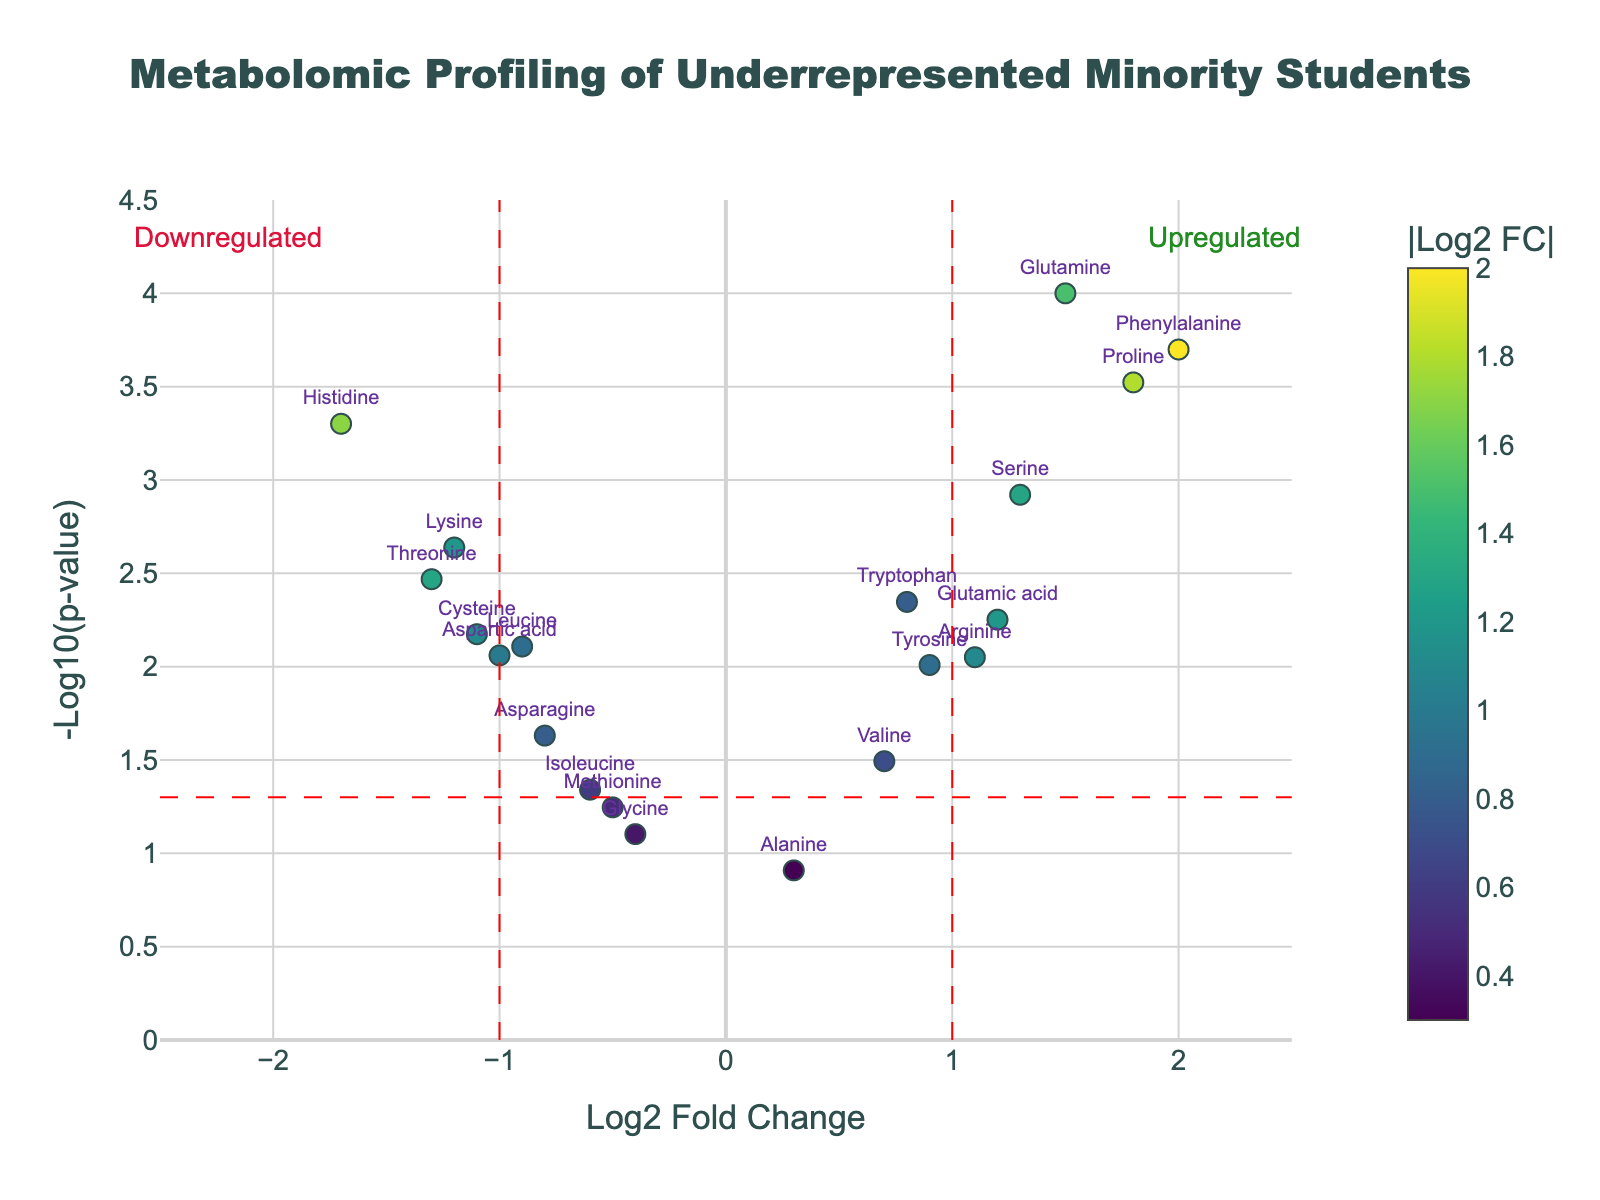How many metabolites have a statistically significant p-value? Statistically significant p-values are typically below 0.05. By examining the y-axis and locating the points above the red-dashed horizontal line (representing the p-value threshold), we can count 15 metabolites as significant.
Answer: 15 Which metabolite has the highest log2 fold change and what is its p-value? To find the metabolite with the highest log2 fold change, look at the x-axis for the data point farthest to the right. The highest log2 fold change (2.0) belongs to Phenylalanine. Its hover text or label provides the p-value, which is 0.0002.
Answer: Phenylalanine, 0.0002 Which metabolite shows the most significant downregulation? The most downregulated metabolite is the one with the lowest log2 fold change on the x-axis. Histidine, with a log2 fold change of -1.7, is the most downregulated, and its p-value is 0.0005.
Answer: Histidine, 0.0005 How many metabolites have a log2 fold change between 1 and -1? Count the number of data points visible between the vertical dashed lines at x = -1 and x = 1 on the x-axis. There are 9 metabolites within this range.
Answer: 9 Which metabolite displayed a significant change but has the least change in log2 fold? The least change in log2 fold among statistically significant (p-value < 0.05) metabolites is when the point is closest to the y-axis (log2 fold change close to 0). Alanine is closest with a log2 fold change of 0.3, but since it's not significant (p-value 0.1234), the next closest is Methionine with a log2 fold change of -0.5 and a p-value 0.0567.
Answer: Methionine, -0.5 What is the average log2 fold change of the significant upregulated metabolites? First, identify significant upregulated metabolites (log2 fold change > 0 and p-value < 0.05): Tryptophan, Glutamine, Proline, Tyrosine, Glutamic acid, Serine, and Arginine. Sum their log2 fold changes (0.8 + 1.5 + 1.8 + 0.9 + 1.2 + 1.3 + 1.1 = 8.6) and divide by 7 (number of metabolites). The average is 8.6/7 ≈ 1.23.
Answer: 1.23 Which metabolite has a higher log2 fold change: Tryptophan or Valine? Compare the log2 fold changes by looking at their x-axis positions. Tryptophan has a log2 fold change of 0.8, while Valine has 0.7. Tryptophan has a higher log2 fold change.
Answer: Tryptophan 